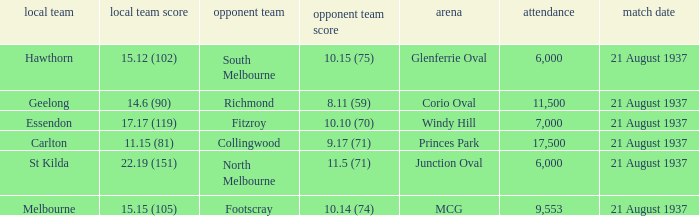Where does South Melbourne play? Glenferrie Oval. 